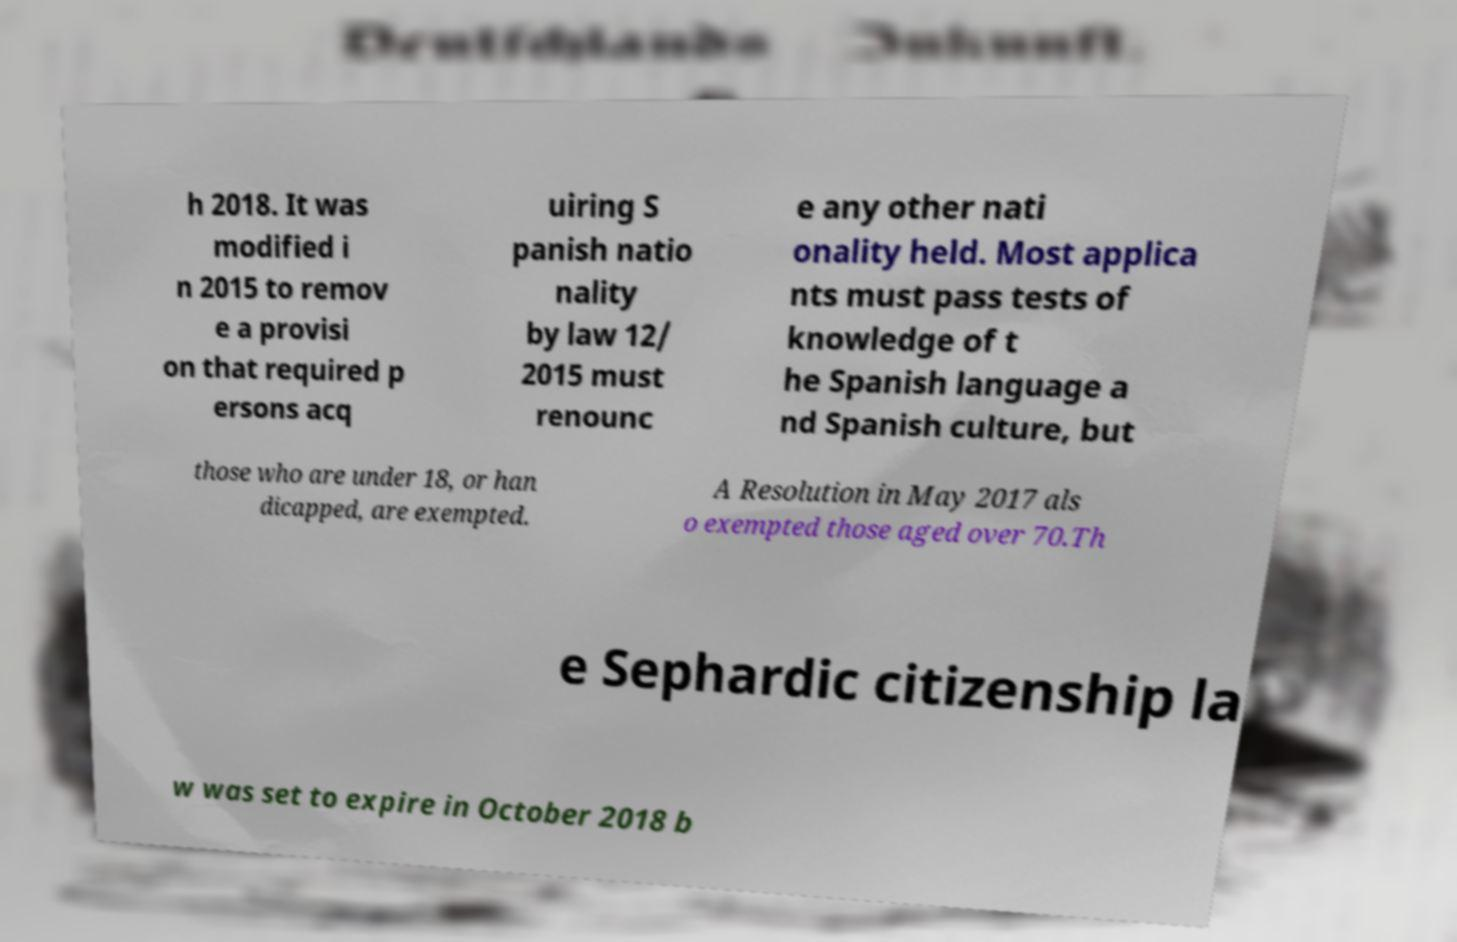Please read and relay the text visible in this image. What does it say? h 2018. It was modified i n 2015 to remov e a provisi on that required p ersons acq uiring S panish natio nality by law 12/ 2015 must renounc e any other nati onality held. Most applica nts must pass tests of knowledge of t he Spanish language a nd Spanish culture, but those who are under 18, or han dicapped, are exempted. A Resolution in May 2017 als o exempted those aged over 70.Th e Sephardic citizenship la w was set to expire in October 2018 b 